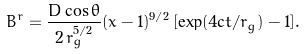Convert formula to latex. <formula><loc_0><loc_0><loc_500><loc_500>B ^ { r } = \frac { D \cos \theta } { 2 \, r _ { g } ^ { 5 / 2 } } ( x - 1 ) ^ { 9 / 2 } \, [ \exp ( 4 c t / r _ { g } ) - 1 ] .</formula> 